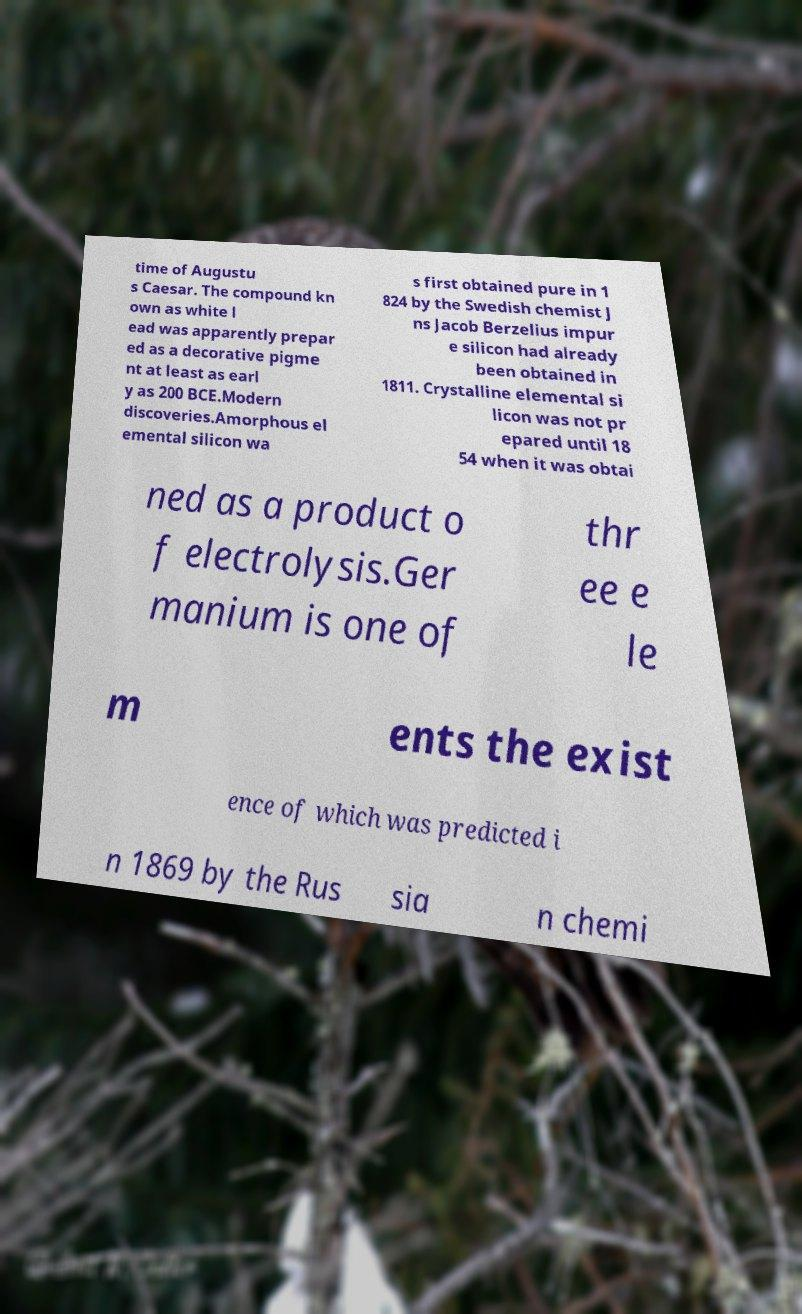Please identify and transcribe the text found in this image. time of Augustu s Caesar. The compound kn own as white l ead was apparently prepar ed as a decorative pigme nt at least as earl y as 200 BCE.Modern discoveries.Amorphous el emental silicon wa s first obtained pure in 1 824 by the Swedish chemist J ns Jacob Berzelius impur e silicon had already been obtained in 1811. Crystalline elemental si licon was not pr epared until 18 54 when it was obtai ned as a product o f electrolysis.Ger manium is one of thr ee e le m ents the exist ence of which was predicted i n 1869 by the Rus sia n chemi 